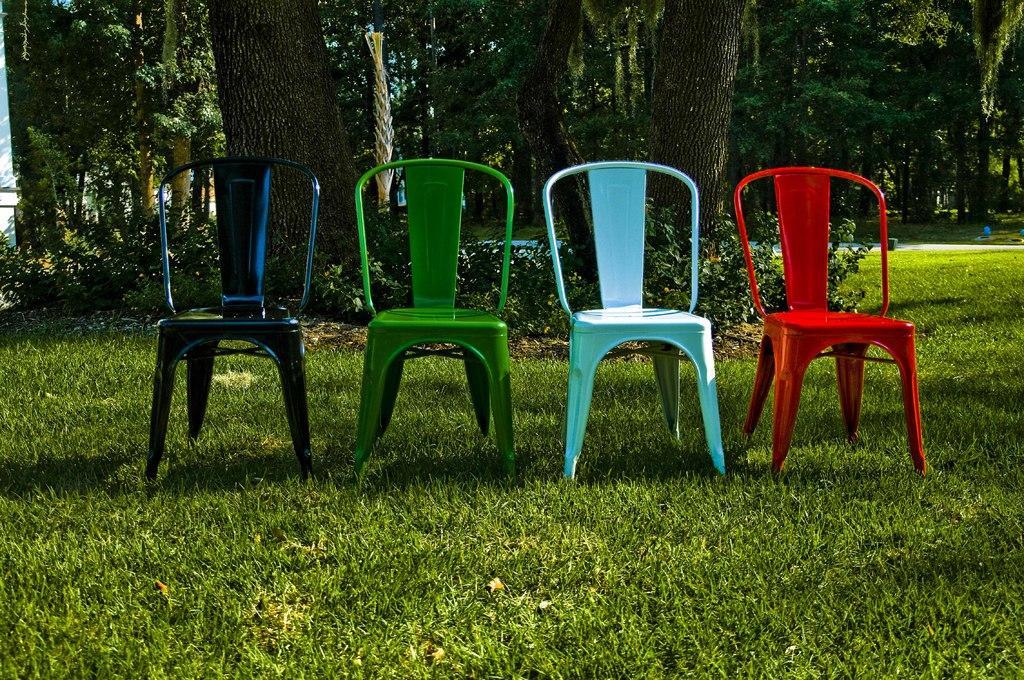How would you summarize this image in a sentence or two? As we can see in the image there are four chairs which are of different colours such as navy blue, green, light blue and red. The chairs are kept on the ground, the ground covered with grass. Behind the chairs there are plants and trees. 